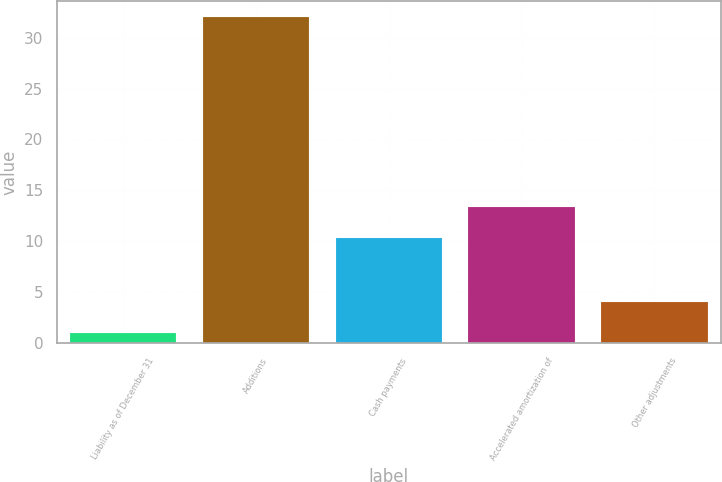<chart> <loc_0><loc_0><loc_500><loc_500><bar_chart><fcel>Liability as of December 31<fcel>Additions<fcel>Cash payments<fcel>Accelerated amortization of<fcel>Other adjustments<nl><fcel>1<fcel>32<fcel>10.3<fcel>13.4<fcel>4.1<nl></chart> 